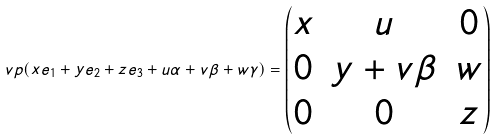Convert formula to latex. <formula><loc_0><loc_0><loc_500><loc_500>\ v p ( x e _ { 1 } + y e _ { 2 } + z e _ { 3 } + u \alpha + v \beta + w \gamma ) = \left ( \begin{matrix} x & u & 0 \\ 0 & y + v \beta & w \\ 0 & 0 & z \end{matrix} \right )</formula> 